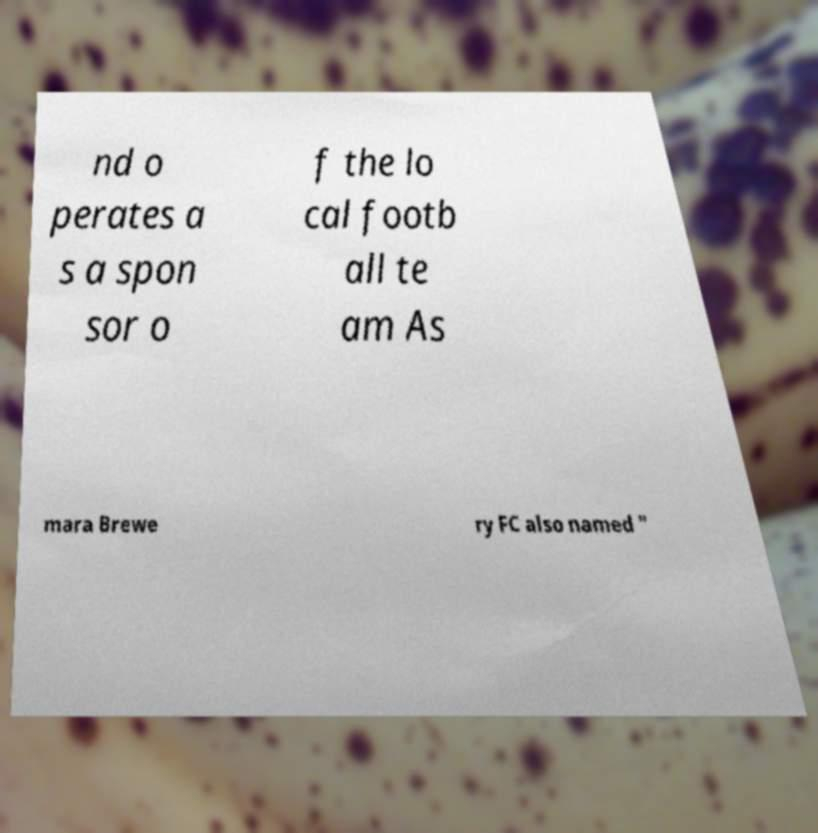Please read and relay the text visible in this image. What does it say? nd o perates a s a spon sor o f the lo cal footb all te am As mara Brewe ry FC also named " 